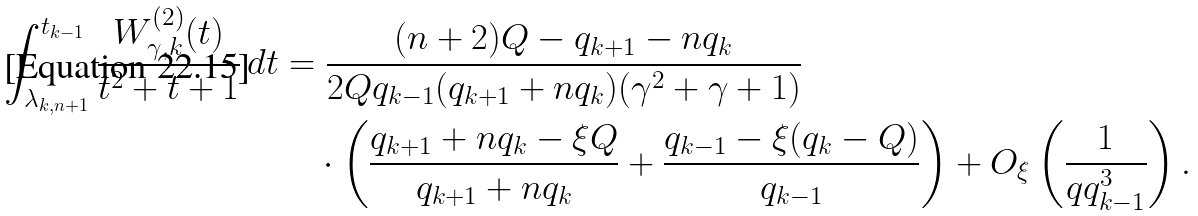Convert formula to latex. <formula><loc_0><loc_0><loc_500><loc_500>\int _ { \lambda _ { k , n + 1 } } ^ { t _ { k - 1 } } \frac { W ^ { ( 2 ) } _ { \gamma , k } ( t ) } { t ^ { 2 } + t + 1 } \, d t & = \frac { ( n + 2 ) Q - q _ { k + 1 } - n q _ { k } } { 2 Q q _ { k - 1 } ( q _ { k + 1 } + n q _ { k } ) ( \gamma ^ { 2 } + \gamma + 1 ) } \\ & \quad \cdot \left ( \frac { q _ { k + 1 } + n q _ { k } - \xi Q } { q _ { k + 1 } + n q _ { k } } + \frac { q _ { k - 1 } - \xi ( q _ { k } - Q ) } { q _ { k - 1 } } \right ) + O _ { \xi } \left ( \frac { 1 } { q q _ { k - 1 } ^ { 3 } } \right ) .</formula> 